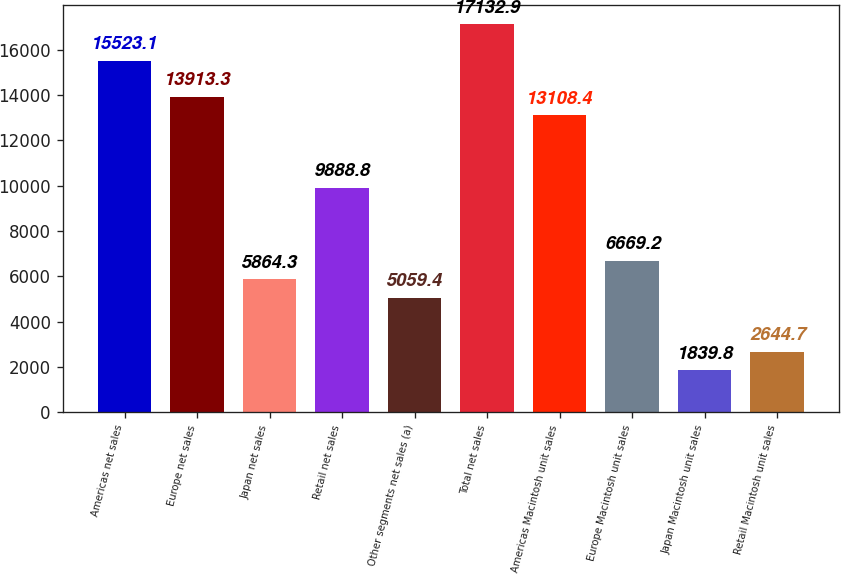Convert chart to OTSL. <chart><loc_0><loc_0><loc_500><loc_500><bar_chart><fcel>Americas net sales<fcel>Europe net sales<fcel>Japan net sales<fcel>Retail net sales<fcel>Other segments net sales (a)<fcel>Total net sales<fcel>Americas Macintosh unit sales<fcel>Europe Macintosh unit sales<fcel>Japan Macintosh unit sales<fcel>Retail Macintosh unit sales<nl><fcel>15523.1<fcel>13913.3<fcel>5864.3<fcel>9888.8<fcel>5059.4<fcel>17132.9<fcel>13108.4<fcel>6669.2<fcel>1839.8<fcel>2644.7<nl></chart> 